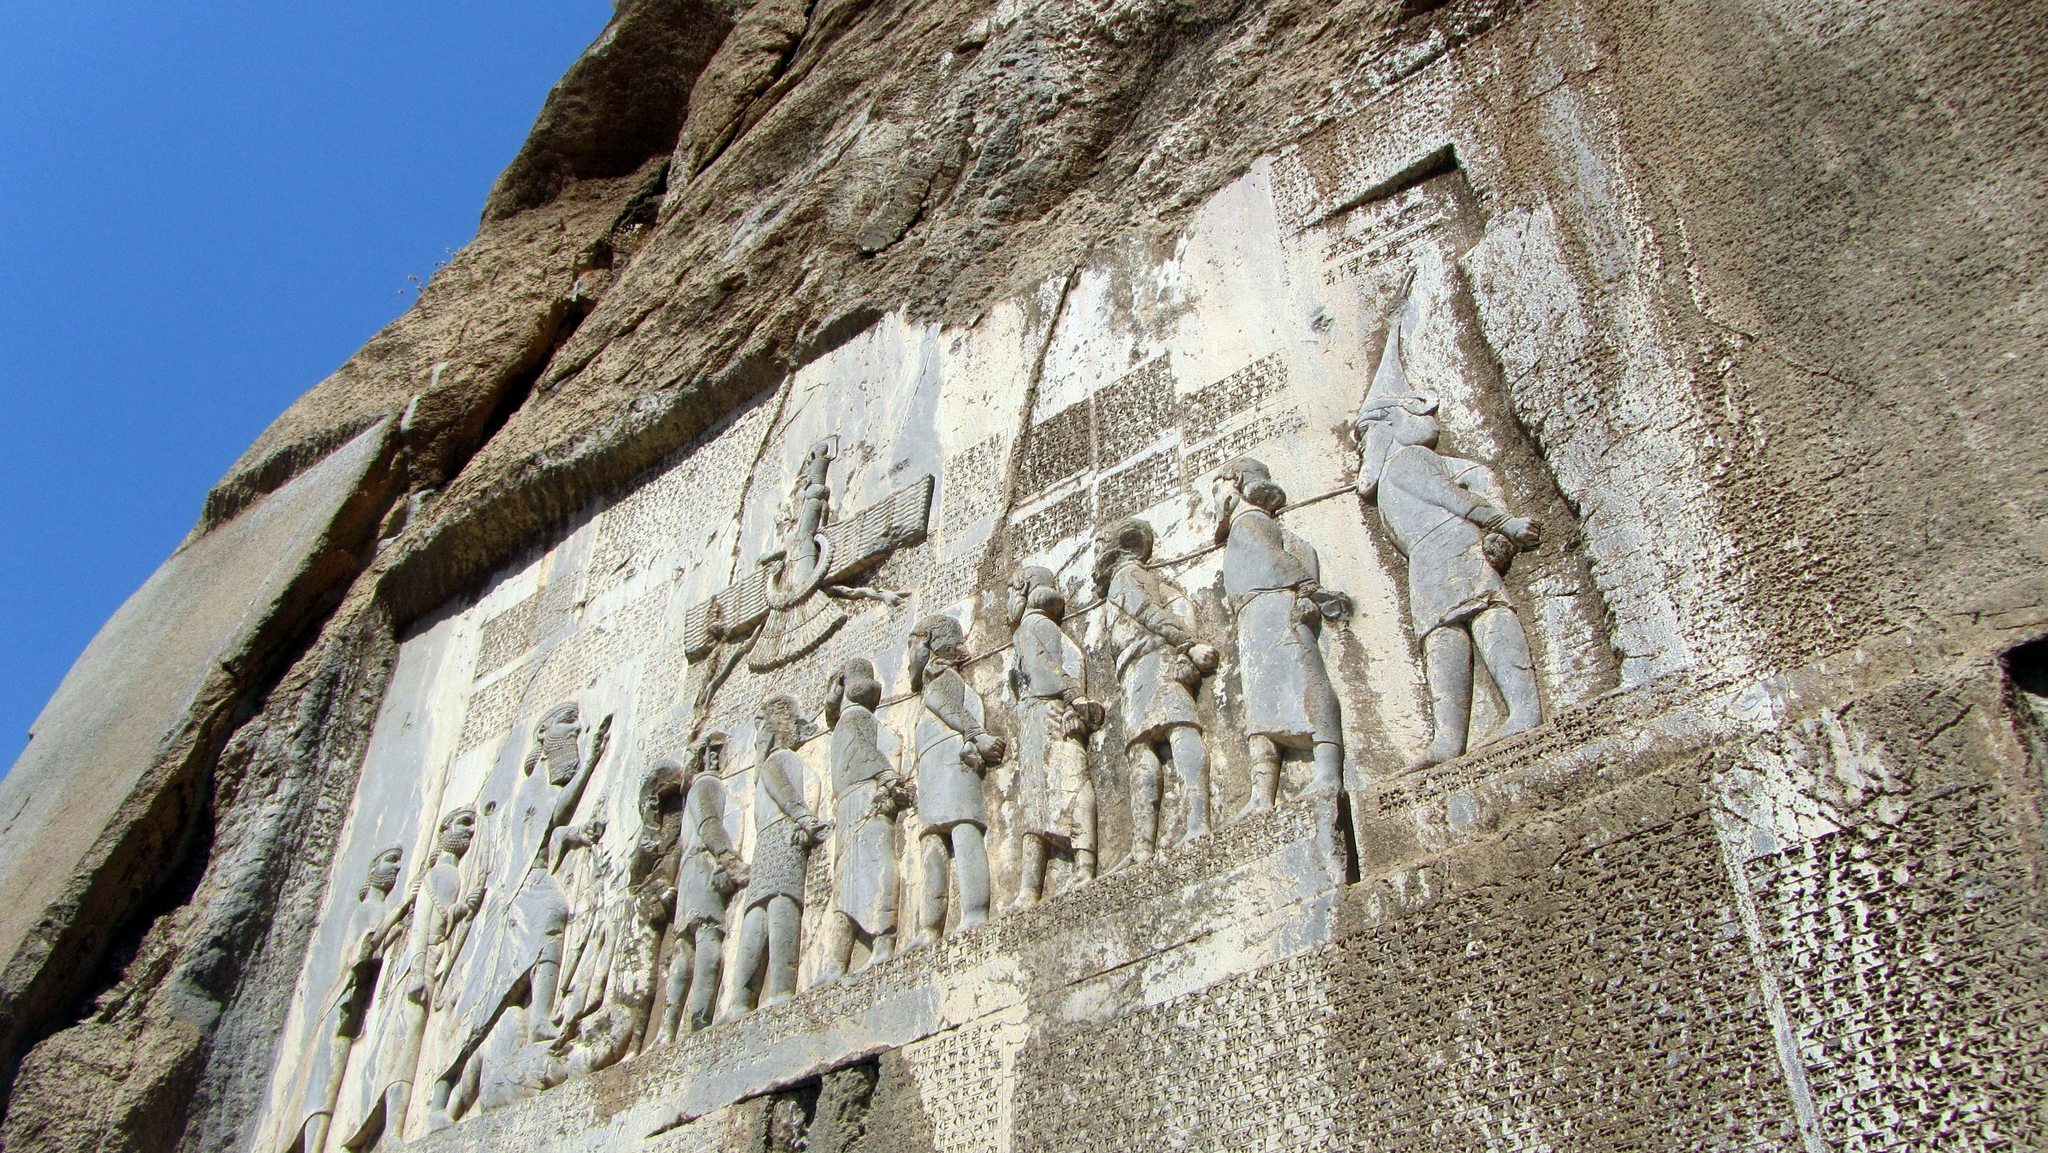Explain the visual content of the image in great detail. The image displays the impressive Behistun Inscription carved into a limestone cliff at Mount Behistun in Kermanshah Province, Iran. From the lower angle of the shot, our view is directed upwards, emphasizing the sheer scale and the intricate detail of the relief sculpture against a clear sky.

The relief prominently features a line of figures, each depicted with remarkable detail in traditional attire, suggesting their roles and ranks in ancient Persian society. The central figure, larger and more detailed, likely represents a king or a deity, underlining authority and divine sanction. The accompanying cuneiform script runs in vertical columns and is notably preserved, written in Old Persian, Elamite, and Babylonian—reflecting the empire's administrative complexity and cultural diversity.

Beyond its archaeological value, the inscription is a critical piece of the puzzle in understanding the lineage and legitimacy of Darius the Great, offering insights into the historical narratives of power, conquest, and governance in the ancient world. With sunlight casting shadows that highlight the depth of the carvings, we gain not only a visual but also a textual connection to the past. 